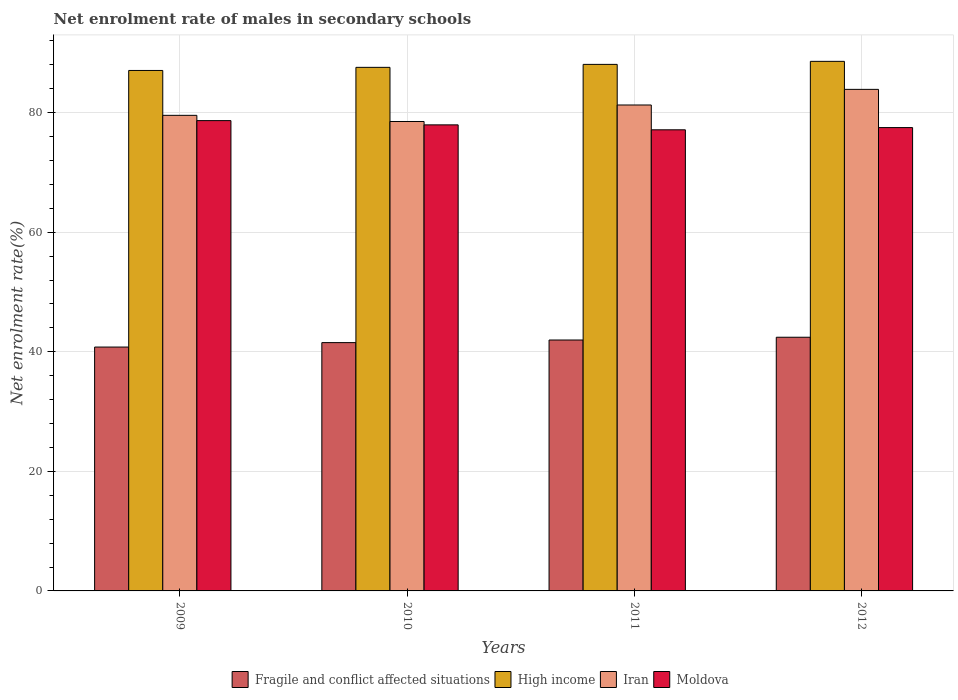How many different coloured bars are there?
Offer a very short reply. 4. How many groups of bars are there?
Your response must be concise. 4. Are the number of bars on each tick of the X-axis equal?
Your response must be concise. Yes. How many bars are there on the 3rd tick from the left?
Your answer should be compact. 4. In how many cases, is the number of bars for a given year not equal to the number of legend labels?
Offer a terse response. 0. What is the net enrolment rate of males in secondary schools in Iran in 2009?
Keep it short and to the point. 79.55. Across all years, what is the maximum net enrolment rate of males in secondary schools in Iran?
Ensure brevity in your answer.  83.9. Across all years, what is the minimum net enrolment rate of males in secondary schools in High income?
Your answer should be very brief. 87.06. In which year was the net enrolment rate of males in secondary schools in Moldova maximum?
Your response must be concise. 2009. In which year was the net enrolment rate of males in secondary schools in Fragile and conflict affected situations minimum?
Your answer should be compact. 2009. What is the total net enrolment rate of males in secondary schools in Fragile and conflict affected situations in the graph?
Offer a very short reply. 166.73. What is the difference between the net enrolment rate of males in secondary schools in High income in 2010 and that in 2011?
Keep it short and to the point. -0.5. What is the difference between the net enrolment rate of males in secondary schools in Fragile and conflict affected situations in 2010 and the net enrolment rate of males in secondary schools in Iran in 2009?
Your answer should be compact. -38.02. What is the average net enrolment rate of males in secondary schools in Fragile and conflict affected situations per year?
Offer a terse response. 41.68. In the year 2012, what is the difference between the net enrolment rate of males in secondary schools in High income and net enrolment rate of males in secondary schools in Fragile and conflict affected situations?
Keep it short and to the point. 46.15. What is the ratio of the net enrolment rate of males in secondary schools in Moldova in 2011 to that in 2012?
Your response must be concise. 1. Is the net enrolment rate of males in secondary schools in Moldova in 2009 less than that in 2011?
Offer a very short reply. No. Is the difference between the net enrolment rate of males in secondary schools in High income in 2009 and 2012 greater than the difference between the net enrolment rate of males in secondary schools in Fragile and conflict affected situations in 2009 and 2012?
Provide a succinct answer. Yes. What is the difference between the highest and the second highest net enrolment rate of males in secondary schools in High income?
Offer a very short reply. 0.51. What is the difference between the highest and the lowest net enrolment rate of males in secondary schools in Moldova?
Ensure brevity in your answer.  1.54. In how many years, is the net enrolment rate of males in secondary schools in Iran greater than the average net enrolment rate of males in secondary schools in Iran taken over all years?
Your answer should be compact. 2. What does the 2nd bar from the right in 2010 represents?
Ensure brevity in your answer.  Iran. Is it the case that in every year, the sum of the net enrolment rate of males in secondary schools in Fragile and conflict affected situations and net enrolment rate of males in secondary schools in High income is greater than the net enrolment rate of males in secondary schools in Moldova?
Provide a succinct answer. Yes. How many bars are there?
Provide a short and direct response. 16. Are all the bars in the graph horizontal?
Keep it short and to the point. No. Are the values on the major ticks of Y-axis written in scientific E-notation?
Give a very brief answer. No. Does the graph contain any zero values?
Offer a terse response. No. Does the graph contain grids?
Your answer should be very brief. Yes. How many legend labels are there?
Your response must be concise. 4. How are the legend labels stacked?
Your answer should be compact. Horizontal. What is the title of the graph?
Your answer should be compact. Net enrolment rate of males in secondary schools. Does "Macao" appear as one of the legend labels in the graph?
Provide a short and direct response. No. What is the label or title of the Y-axis?
Provide a short and direct response. Net enrolment rate(%). What is the Net enrolment rate(%) in Fragile and conflict affected situations in 2009?
Your answer should be very brief. 40.79. What is the Net enrolment rate(%) in High income in 2009?
Make the answer very short. 87.06. What is the Net enrolment rate(%) of Iran in 2009?
Provide a short and direct response. 79.55. What is the Net enrolment rate(%) in Moldova in 2009?
Make the answer very short. 78.67. What is the Net enrolment rate(%) of Fragile and conflict affected situations in 2010?
Keep it short and to the point. 41.53. What is the Net enrolment rate(%) of High income in 2010?
Provide a short and direct response. 87.58. What is the Net enrolment rate(%) of Iran in 2010?
Your answer should be very brief. 78.52. What is the Net enrolment rate(%) in Moldova in 2010?
Make the answer very short. 77.96. What is the Net enrolment rate(%) of Fragile and conflict affected situations in 2011?
Make the answer very short. 41.97. What is the Net enrolment rate(%) in High income in 2011?
Your answer should be compact. 88.08. What is the Net enrolment rate(%) in Iran in 2011?
Make the answer very short. 81.28. What is the Net enrolment rate(%) in Moldova in 2011?
Offer a very short reply. 77.13. What is the Net enrolment rate(%) in Fragile and conflict affected situations in 2012?
Provide a succinct answer. 42.44. What is the Net enrolment rate(%) in High income in 2012?
Give a very brief answer. 88.58. What is the Net enrolment rate(%) in Iran in 2012?
Ensure brevity in your answer.  83.9. What is the Net enrolment rate(%) in Moldova in 2012?
Provide a succinct answer. 77.5. Across all years, what is the maximum Net enrolment rate(%) of Fragile and conflict affected situations?
Your response must be concise. 42.44. Across all years, what is the maximum Net enrolment rate(%) of High income?
Your response must be concise. 88.58. Across all years, what is the maximum Net enrolment rate(%) of Iran?
Provide a succinct answer. 83.9. Across all years, what is the maximum Net enrolment rate(%) in Moldova?
Offer a very short reply. 78.67. Across all years, what is the minimum Net enrolment rate(%) in Fragile and conflict affected situations?
Offer a very short reply. 40.79. Across all years, what is the minimum Net enrolment rate(%) of High income?
Your answer should be very brief. 87.06. Across all years, what is the minimum Net enrolment rate(%) of Iran?
Offer a terse response. 78.52. Across all years, what is the minimum Net enrolment rate(%) in Moldova?
Keep it short and to the point. 77.13. What is the total Net enrolment rate(%) of Fragile and conflict affected situations in the graph?
Offer a very short reply. 166.73. What is the total Net enrolment rate(%) in High income in the graph?
Keep it short and to the point. 351.3. What is the total Net enrolment rate(%) of Iran in the graph?
Your answer should be very brief. 323.26. What is the total Net enrolment rate(%) in Moldova in the graph?
Keep it short and to the point. 311.26. What is the difference between the Net enrolment rate(%) in Fragile and conflict affected situations in 2009 and that in 2010?
Your response must be concise. -0.74. What is the difference between the Net enrolment rate(%) in High income in 2009 and that in 2010?
Offer a terse response. -0.52. What is the difference between the Net enrolment rate(%) of Iran in 2009 and that in 2010?
Make the answer very short. 1.03. What is the difference between the Net enrolment rate(%) of Moldova in 2009 and that in 2010?
Your response must be concise. 0.71. What is the difference between the Net enrolment rate(%) in Fragile and conflict affected situations in 2009 and that in 2011?
Your response must be concise. -1.18. What is the difference between the Net enrolment rate(%) in High income in 2009 and that in 2011?
Provide a short and direct response. -1.02. What is the difference between the Net enrolment rate(%) in Iran in 2009 and that in 2011?
Offer a very short reply. -1.73. What is the difference between the Net enrolment rate(%) of Moldova in 2009 and that in 2011?
Make the answer very short. 1.54. What is the difference between the Net enrolment rate(%) of Fragile and conflict affected situations in 2009 and that in 2012?
Provide a succinct answer. -1.64. What is the difference between the Net enrolment rate(%) of High income in 2009 and that in 2012?
Ensure brevity in your answer.  -1.52. What is the difference between the Net enrolment rate(%) of Iran in 2009 and that in 2012?
Offer a terse response. -4.34. What is the difference between the Net enrolment rate(%) in Moldova in 2009 and that in 2012?
Give a very brief answer. 1.16. What is the difference between the Net enrolment rate(%) of Fragile and conflict affected situations in 2010 and that in 2011?
Your response must be concise. -0.44. What is the difference between the Net enrolment rate(%) in High income in 2010 and that in 2011?
Your answer should be very brief. -0.5. What is the difference between the Net enrolment rate(%) in Iran in 2010 and that in 2011?
Offer a terse response. -2.76. What is the difference between the Net enrolment rate(%) in Moldova in 2010 and that in 2011?
Provide a short and direct response. 0.83. What is the difference between the Net enrolment rate(%) of Fragile and conflict affected situations in 2010 and that in 2012?
Keep it short and to the point. -0.9. What is the difference between the Net enrolment rate(%) of High income in 2010 and that in 2012?
Your answer should be very brief. -1. What is the difference between the Net enrolment rate(%) of Iran in 2010 and that in 2012?
Provide a succinct answer. -5.38. What is the difference between the Net enrolment rate(%) of Moldova in 2010 and that in 2012?
Make the answer very short. 0.46. What is the difference between the Net enrolment rate(%) of Fragile and conflict affected situations in 2011 and that in 2012?
Your answer should be very brief. -0.46. What is the difference between the Net enrolment rate(%) of High income in 2011 and that in 2012?
Your response must be concise. -0.51. What is the difference between the Net enrolment rate(%) of Iran in 2011 and that in 2012?
Your answer should be compact. -2.61. What is the difference between the Net enrolment rate(%) of Moldova in 2011 and that in 2012?
Your response must be concise. -0.37. What is the difference between the Net enrolment rate(%) in Fragile and conflict affected situations in 2009 and the Net enrolment rate(%) in High income in 2010?
Offer a very short reply. -46.79. What is the difference between the Net enrolment rate(%) in Fragile and conflict affected situations in 2009 and the Net enrolment rate(%) in Iran in 2010?
Give a very brief answer. -37.73. What is the difference between the Net enrolment rate(%) in Fragile and conflict affected situations in 2009 and the Net enrolment rate(%) in Moldova in 2010?
Your answer should be compact. -37.17. What is the difference between the Net enrolment rate(%) of High income in 2009 and the Net enrolment rate(%) of Iran in 2010?
Make the answer very short. 8.54. What is the difference between the Net enrolment rate(%) in High income in 2009 and the Net enrolment rate(%) in Moldova in 2010?
Offer a terse response. 9.1. What is the difference between the Net enrolment rate(%) of Iran in 2009 and the Net enrolment rate(%) of Moldova in 2010?
Offer a very short reply. 1.59. What is the difference between the Net enrolment rate(%) of Fragile and conflict affected situations in 2009 and the Net enrolment rate(%) of High income in 2011?
Offer a terse response. -47.28. What is the difference between the Net enrolment rate(%) of Fragile and conflict affected situations in 2009 and the Net enrolment rate(%) of Iran in 2011?
Offer a terse response. -40.49. What is the difference between the Net enrolment rate(%) of Fragile and conflict affected situations in 2009 and the Net enrolment rate(%) of Moldova in 2011?
Your response must be concise. -36.34. What is the difference between the Net enrolment rate(%) in High income in 2009 and the Net enrolment rate(%) in Iran in 2011?
Offer a terse response. 5.78. What is the difference between the Net enrolment rate(%) of High income in 2009 and the Net enrolment rate(%) of Moldova in 2011?
Offer a very short reply. 9.93. What is the difference between the Net enrolment rate(%) in Iran in 2009 and the Net enrolment rate(%) in Moldova in 2011?
Provide a succinct answer. 2.42. What is the difference between the Net enrolment rate(%) of Fragile and conflict affected situations in 2009 and the Net enrolment rate(%) of High income in 2012?
Provide a succinct answer. -47.79. What is the difference between the Net enrolment rate(%) in Fragile and conflict affected situations in 2009 and the Net enrolment rate(%) in Iran in 2012?
Offer a terse response. -43.11. What is the difference between the Net enrolment rate(%) in Fragile and conflict affected situations in 2009 and the Net enrolment rate(%) in Moldova in 2012?
Keep it short and to the point. -36.71. What is the difference between the Net enrolment rate(%) of High income in 2009 and the Net enrolment rate(%) of Iran in 2012?
Your answer should be very brief. 3.16. What is the difference between the Net enrolment rate(%) in High income in 2009 and the Net enrolment rate(%) in Moldova in 2012?
Offer a very short reply. 9.56. What is the difference between the Net enrolment rate(%) in Iran in 2009 and the Net enrolment rate(%) in Moldova in 2012?
Offer a very short reply. 2.05. What is the difference between the Net enrolment rate(%) in Fragile and conflict affected situations in 2010 and the Net enrolment rate(%) in High income in 2011?
Ensure brevity in your answer.  -46.54. What is the difference between the Net enrolment rate(%) of Fragile and conflict affected situations in 2010 and the Net enrolment rate(%) of Iran in 2011?
Your answer should be compact. -39.75. What is the difference between the Net enrolment rate(%) in Fragile and conflict affected situations in 2010 and the Net enrolment rate(%) in Moldova in 2011?
Your answer should be very brief. -35.6. What is the difference between the Net enrolment rate(%) of High income in 2010 and the Net enrolment rate(%) of Iran in 2011?
Your answer should be very brief. 6.3. What is the difference between the Net enrolment rate(%) in High income in 2010 and the Net enrolment rate(%) in Moldova in 2011?
Provide a short and direct response. 10.45. What is the difference between the Net enrolment rate(%) in Iran in 2010 and the Net enrolment rate(%) in Moldova in 2011?
Keep it short and to the point. 1.39. What is the difference between the Net enrolment rate(%) in Fragile and conflict affected situations in 2010 and the Net enrolment rate(%) in High income in 2012?
Offer a very short reply. -47.05. What is the difference between the Net enrolment rate(%) in Fragile and conflict affected situations in 2010 and the Net enrolment rate(%) in Iran in 2012?
Offer a terse response. -42.36. What is the difference between the Net enrolment rate(%) of Fragile and conflict affected situations in 2010 and the Net enrolment rate(%) of Moldova in 2012?
Your answer should be compact. -35.97. What is the difference between the Net enrolment rate(%) of High income in 2010 and the Net enrolment rate(%) of Iran in 2012?
Make the answer very short. 3.68. What is the difference between the Net enrolment rate(%) of High income in 2010 and the Net enrolment rate(%) of Moldova in 2012?
Your answer should be very brief. 10.08. What is the difference between the Net enrolment rate(%) in Fragile and conflict affected situations in 2011 and the Net enrolment rate(%) in High income in 2012?
Your response must be concise. -46.61. What is the difference between the Net enrolment rate(%) in Fragile and conflict affected situations in 2011 and the Net enrolment rate(%) in Iran in 2012?
Your answer should be very brief. -41.93. What is the difference between the Net enrolment rate(%) in Fragile and conflict affected situations in 2011 and the Net enrolment rate(%) in Moldova in 2012?
Offer a very short reply. -35.53. What is the difference between the Net enrolment rate(%) in High income in 2011 and the Net enrolment rate(%) in Iran in 2012?
Ensure brevity in your answer.  4.18. What is the difference between the Net enrolment rate(%) of High income in 2011 and the Net enrolment rate(%) of Moldova in 2012?
Your response must be concise. 10.57. What is the difference between the Net enrolment rate(%) of Iran in 2011 and the Net enrolment rate(%) of Moldova in 2012?
Give a very brief answer. 3.78. What is the average Net enrolment rate(%) of Fragile and conflict affected situations per year?
Provide a short and direct response. 41.68. What is the average Net enrolment rate(%) of High income per year?
Provide a succinct answer. 87.83. What is the average Net enrolment rate(%) in Iran per year?
Provide a succinct answer. 80.81. What is the average Net enrolment rate(%) in Moldova per year?
Your answer should be compact. 77.82. In the year 2009, what is the difference between the Net enrolment rate(%) of Fragile and conflict affected situations and Net enrolment rate(%) of High income?
Give a very brief answer. -46.27. In the year 2009, what is the difference between the Net enrolment rate(%) in Fragile and conflict affected situations and Net enrolment rate(%) in Iran?
Provide a short and direct response. -38.76. In the year 2009, what is the difference between the Net enrolment rate(%) of Fragile and conflict affected situations and Net enrolment rate(%) of Moldova?
Offer a very short reply. -37.88. In the year 2009, what is the difference between the Net enrolment rate(%) in High income and Net enrolment rate(%) in Iran?
Provide a short and direct response. 7.51. In the year 2009, what is the difference between the Net enrolment rate(%) in High income and Net enrolment rate(%) in Moldova?
Provide a succinct answer. 8.39. In the year 2009, what is the difference between the Net enrolment rate(%) in Iran and Net enrolment rate(%) in Moldova?
Ensure brevity in your answer.  0.89. In the year 2010, what is the difference between the Net enrolment rate(%) of Fragile and conflict affected situations and Net enrolment rate(%) of High income?
Keep it short and to the point. -46.05. In the year 2010, what is the difference between the Net enrolment rate(%) of Fragile and conflict affected situations and Net enrolment rate(%) of Iran?
Keep it short and to the point. -36.99. In the year 2010, what is the difference between the Net enrolment rate(%) in Fragile and conflict affected situations and Net enrolment rate(%) in Moldova?
Give a very brief answer. -36.42. In the year 2010, what is the difference between the Net enrolment rate(%) of High income and Net enrolment rate(%) of Iran?
Provide a short and direct response. 9.06. In the year 2010, what is the difference between the Net enrolment rate(%) of High income and Net enrolment rate(%) of Moldova?
Keep it short and to the point. 9.62. In the year 2010, what is the difference between the Net enrolment rate(%) of Iran and Net enrolment rate(%) of Moldova?
Make the answer very short. 0.56. In the year 2011, what is the difference between the Net enrolment rate(%) in Fragile and conflict affected situations and Net enrolment rate(%) in High income?
Ensure brevity in your answer.  -46.1. In the year 2011, what is the difference between the Net enrolment rate(%) in Fragile and conflict affected situations and Net enrolment rate(%) in Iran?
Offer a terse response. -39.31. In the year 2011, what is the difference between the Net enrolment rate(%) of Fragile and conflict affected situations and Net enrolment rate(%) of Moldova?
Offer a terse response. -35.16. In the year 2011, what is the difference between the Net enrolment rate(%) of High income and Net enrolment rate(%) of Iran?
Keep it short and to the point. 6.79. In the year 2011, what is the difference between the Net enrolment rate(%) in High income and Net enrolment rate(%) in Moldova?
Provide a succinct answer. 10.94. In the year 2011, what is the difference between the Net enrolment rate(%) of Iran and Net enrolment rate(%) of Moldova?
Make the answer very short. 4.15. In the year 2012, what is the difference between the Net enrolment rate(%) in Fragile and conflict affected situations and Net enrolment rate(%) in High income?
Provide a succinct answer. -46.15. In the year 2012, what is the difference between the Net enrolment rate(%) of Fragile and conflict affected situations and Net enrolment rate(%) of Iran?
Ensure brevity in your answer.  -41.46. In the year 2012, what is the difference between the Net enrolment rate(%) in Fragile and conflict affected situations and Net enrolment rate(%) in Moldova?
Offer a terse response. -35.07. In the year 2012, what is the difference between the Net enrolment rate(%) in High income and Net enrolment rate(%) in Iran?
Keep it short and to the point. 4.68. In the year 2012, what is the difference between the Net enrolment rate(%) in High income and Net enrolment rate(%) in Moldova?
Keep it short and to the point. 11.08. In the year 2012, what is the difference between the Net enrolment rate(%) in Iran and Net enrolment rate(%) in Moldova?
Your answer should be compact. 6.39. What is the ratio of the Net enrolment rate(%) in Fragile and conflict affected situations in 2009 to that in 2010?
Offer a terse response. 0.98. What is the ratio of the Net enrolment rate(%) in Iran in 2009 to that in 2010?
Provide a short and direct response. 1.01. What is the ratio of the Net enrolment rate(%) in Moldova in 2009 to that in 2010?
Ensure brevity in your answer.  1.01. What is the ratio of the Net enrolment rate(%) of Fragile and conflict affected situations in 2009 to that in 2011?
Keep it short and to the point. 0.97. What is the ratio of the Net enrolment rate(%) in High income in 2009 to that in 2011?
Offer a terse response. 0.99. What is the ratio of the Net enrolment rate(%) of Iran in 2009 to that in 2011?
Your response must be concise. 0.98. What is the ratio of the Net enrolment rate(%) in Moldova in 2009 to that in 2011?
Your answer should be compact. 1.02. What is the ratio of the Net enrolment rate(%) in Fragile and conflict affected situations in 2009 to that in 2012?
Provide a short and direct response. 0.96. What is the ratio of the Net enrolment rate(%) in High income in 2009 to that in 2012?
Keep it short and to the point. 0.98. What is the ratio of the Net enrolment rate(%) in Iran in 2009 to that in 2012?
Your answer should be very brief. 0.95. What is the ratio of the Net enrolment rate(%) in Fragile and conflict affected situations in 2010 to that in 2011?
Your answer should be compact. 0.99. What is the ratio of the Net enrolment rate(%) of Moldova in 2010 to that in 2011?
Make the answer very short. 1.01. What is the ratio of the Net enrolment rate(%) in Fragile and conflict affected situations in 2010 to that in 2012?
Make the answer very short. 0.98. What is the ratio of the Net enrolment rate(%) in High income in 2010 to that in 2012?
Provide a short and direct response. 0.99. What is the ratio of the Net enrolment rate(%) in Iran in 2010 to that in 2012?
Your response must be concise. 0.94. What is the ratio of the Net enrolment rate(%) of Moldova in 2010 to that in 2012?
Keep it short and to the point. 1.01. What is the ratio of the Net enrolment rate(%) of Fragile and conflict affected situations in 2011 to that in 2012?
Offer a terse response. 0.99. What is the ratio of the Net enrolment rate(%) of Iran in 2011 to that in 2012?
Provide a short and direct response. 0.97. What is the ratio of the Net enrolment rate(%) in Moldova in 2011 to that in 2012?
Your answer should be compact. 1. What is the difference between the highest and the second highest Net enrolment rate(%) in Fragile and conflict affected situations?
Provide a short and direct response. 0.46. What is the difference between the highest and the second highest Net enrolment rate(%) of High income?
Give a very brief answer. 0.51. What is the difference between the highest and the second highest Net enrolment rate(%) of Iran?
Ensure brevity in your answer.  2.61. What is the difference between the highest and the second highest Net enrolment rate(%) in Moldova?
Provide a succinct answer. 0.71. What is the difference between the highest and the lowest Net enrolment rate(%) in Fragile and conflict affected situations?
Your response must be concise. 1.64. What is the difference between the highest and the lowest Net enrolment rate(%) in High income?
Your response must be concise. 1.52. What is the difference between the highest and the lowest Net enrolment rate(%) of Iran?
Ensure brevity in your answer.  5.38. What is the difference between the highest and the lowest Net enrolment rate(%) of Moldova?
Make the answer very short. 1.54. 